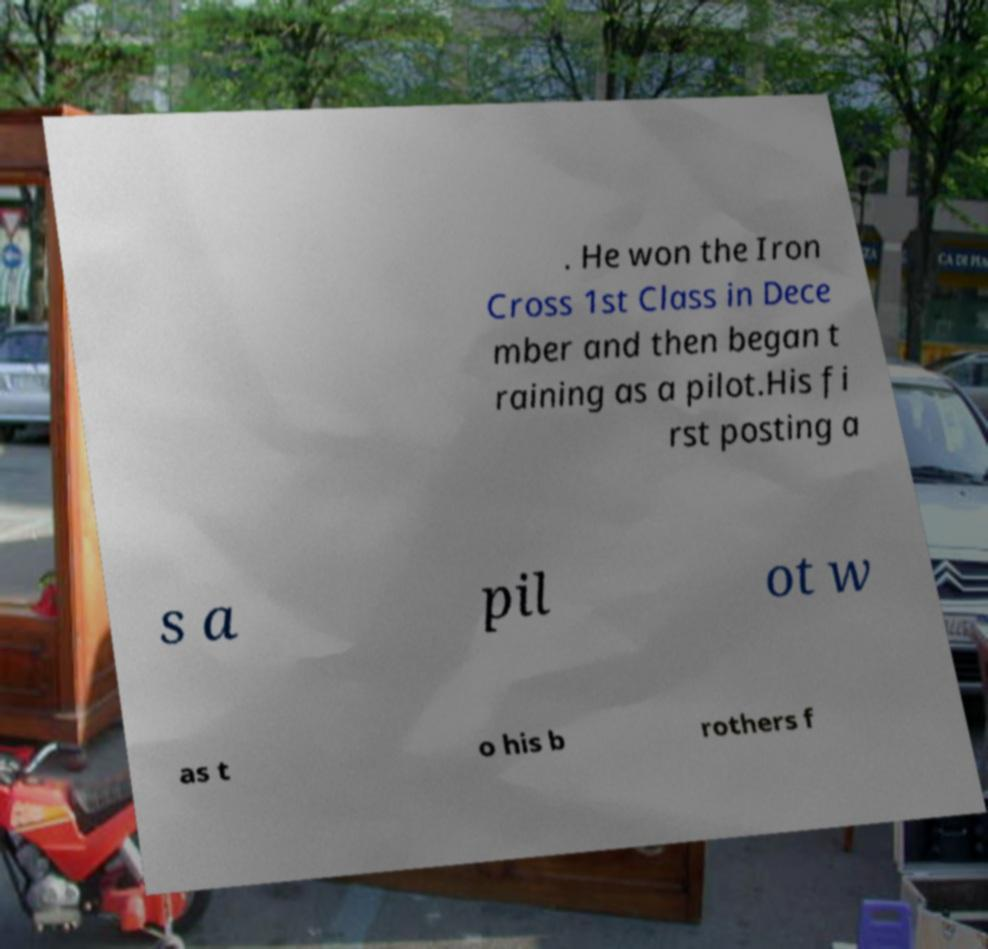Could you extract and type out the text from this image? . He won the Iron Cross 1st Class in Dece mber and then began t raining as a pilot.His fi rst posting a s a pil ot w as t o his b rothers f 